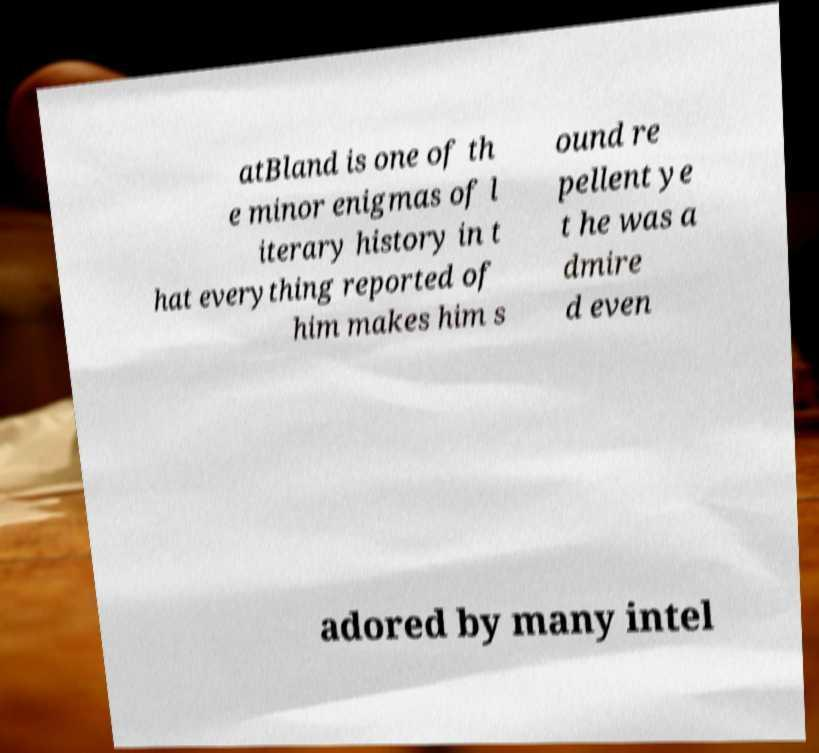What messages or text are displayed in this image? I need them in a readable, typed format. atBland is one of th e minor enigmas of l iterary history in t hat everything reported of him makes him s ound re pellent ye t he was a dmire d even adored by many intel 